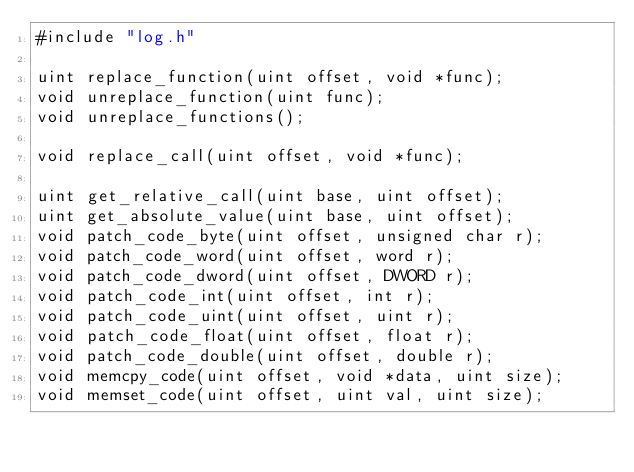<code> <loc_0><loc_0><loc_500><loc_500><_C_>#include "log.h"

uint replace_function(uint offset, void *func);
void unreplace_function(uint func);
void unreplace_functions();

void replace_call(uint offset, void *func);

uint get_relative_call(uint base, uint offset);
uint get_absolute_value(uint base, uint offset);
void patch_code_byte(uint offset, unsigned char r);
void patch_code_word(uint offset, word r);
void patch_code_dword(uint offset, DWORD r);
void patch_code_int(uint offset, int r);
void patch_code_uint(uint offset, uint r);
void patch_code_float(uint offset, float r);
void patch_code_double(uint offset, double r);
void memcpy_code(uint offset, void *data, uint size);
void memset_code(uint offset, uint val, uint size);
</code> 